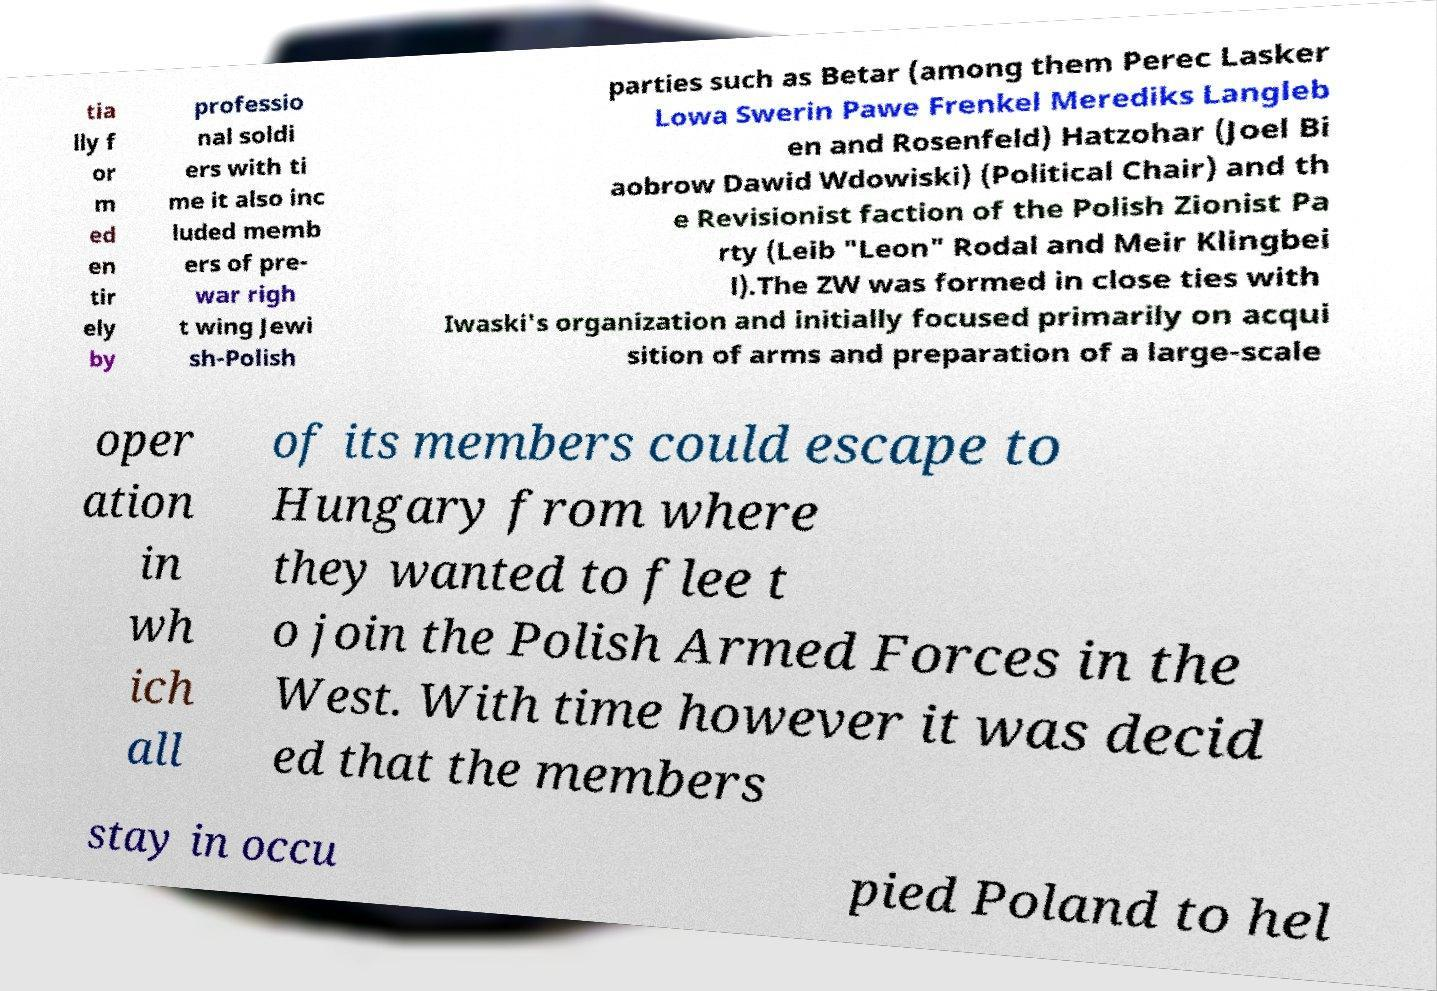For documentation purposes, I need the text within this image transcribed. Could you provide that? tia lly f or m ed en tir ely by professio nal soldi ers with ti me it also inc luded memb ers of pre- war righ t wing Jewi sh-Polish parties such as Betar (among them Perec Lasker Lowa Swerin Pawe Frenkel Merediks Langleb en and Rosenfeld) Hatzohar (Joel Bi aobrow Dawid Wdowiski) (Political Chair) and th e Revisionist faction of the Polish Zionist Pa rty (Leib "Leon" Rodal and Meir Klingbei l).The ZW was formed in close ties with Iwaski's organization and initially focused primarily on acqui sition of arms and preparation of a large-scale oper ation in wh ich all of its members could escape to Hungary from where they wanted to flee t o join the Polish Armed Forces in the West. With time however it was decid ed that the members stay in occu pied Poland to hel 